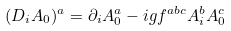<formula> <loc_0><loc_0><loc_500><loc_500>( D _ { i } A _ { 0 } ) ^ { a } = \partial _ { i } A _ { 0 } ^ { a } - i g f ^ { a b c } A _ { i } ^ { b } A _ { 0 } ^ { c }</formula> 